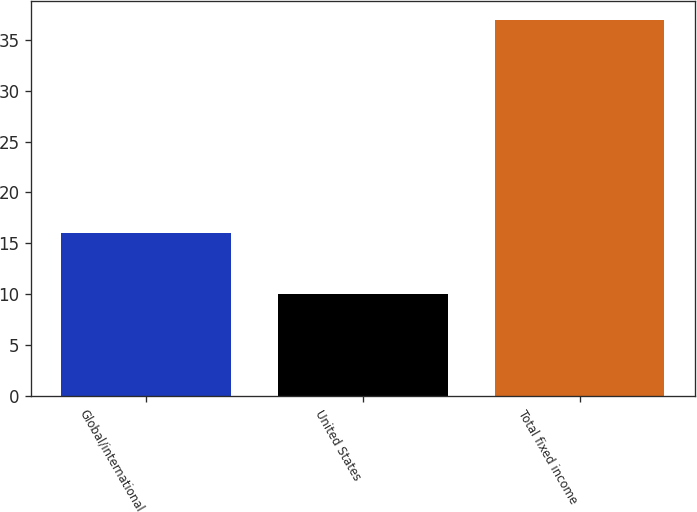Convert chart. <chart><loc_0><loc_0><loc_500><loc_500><bar_chart><fcel>Global/international<fcel>United States<fcel>Total fixed income<nl><fcel>16<fcel>10<fcel>37<nl></chart> 